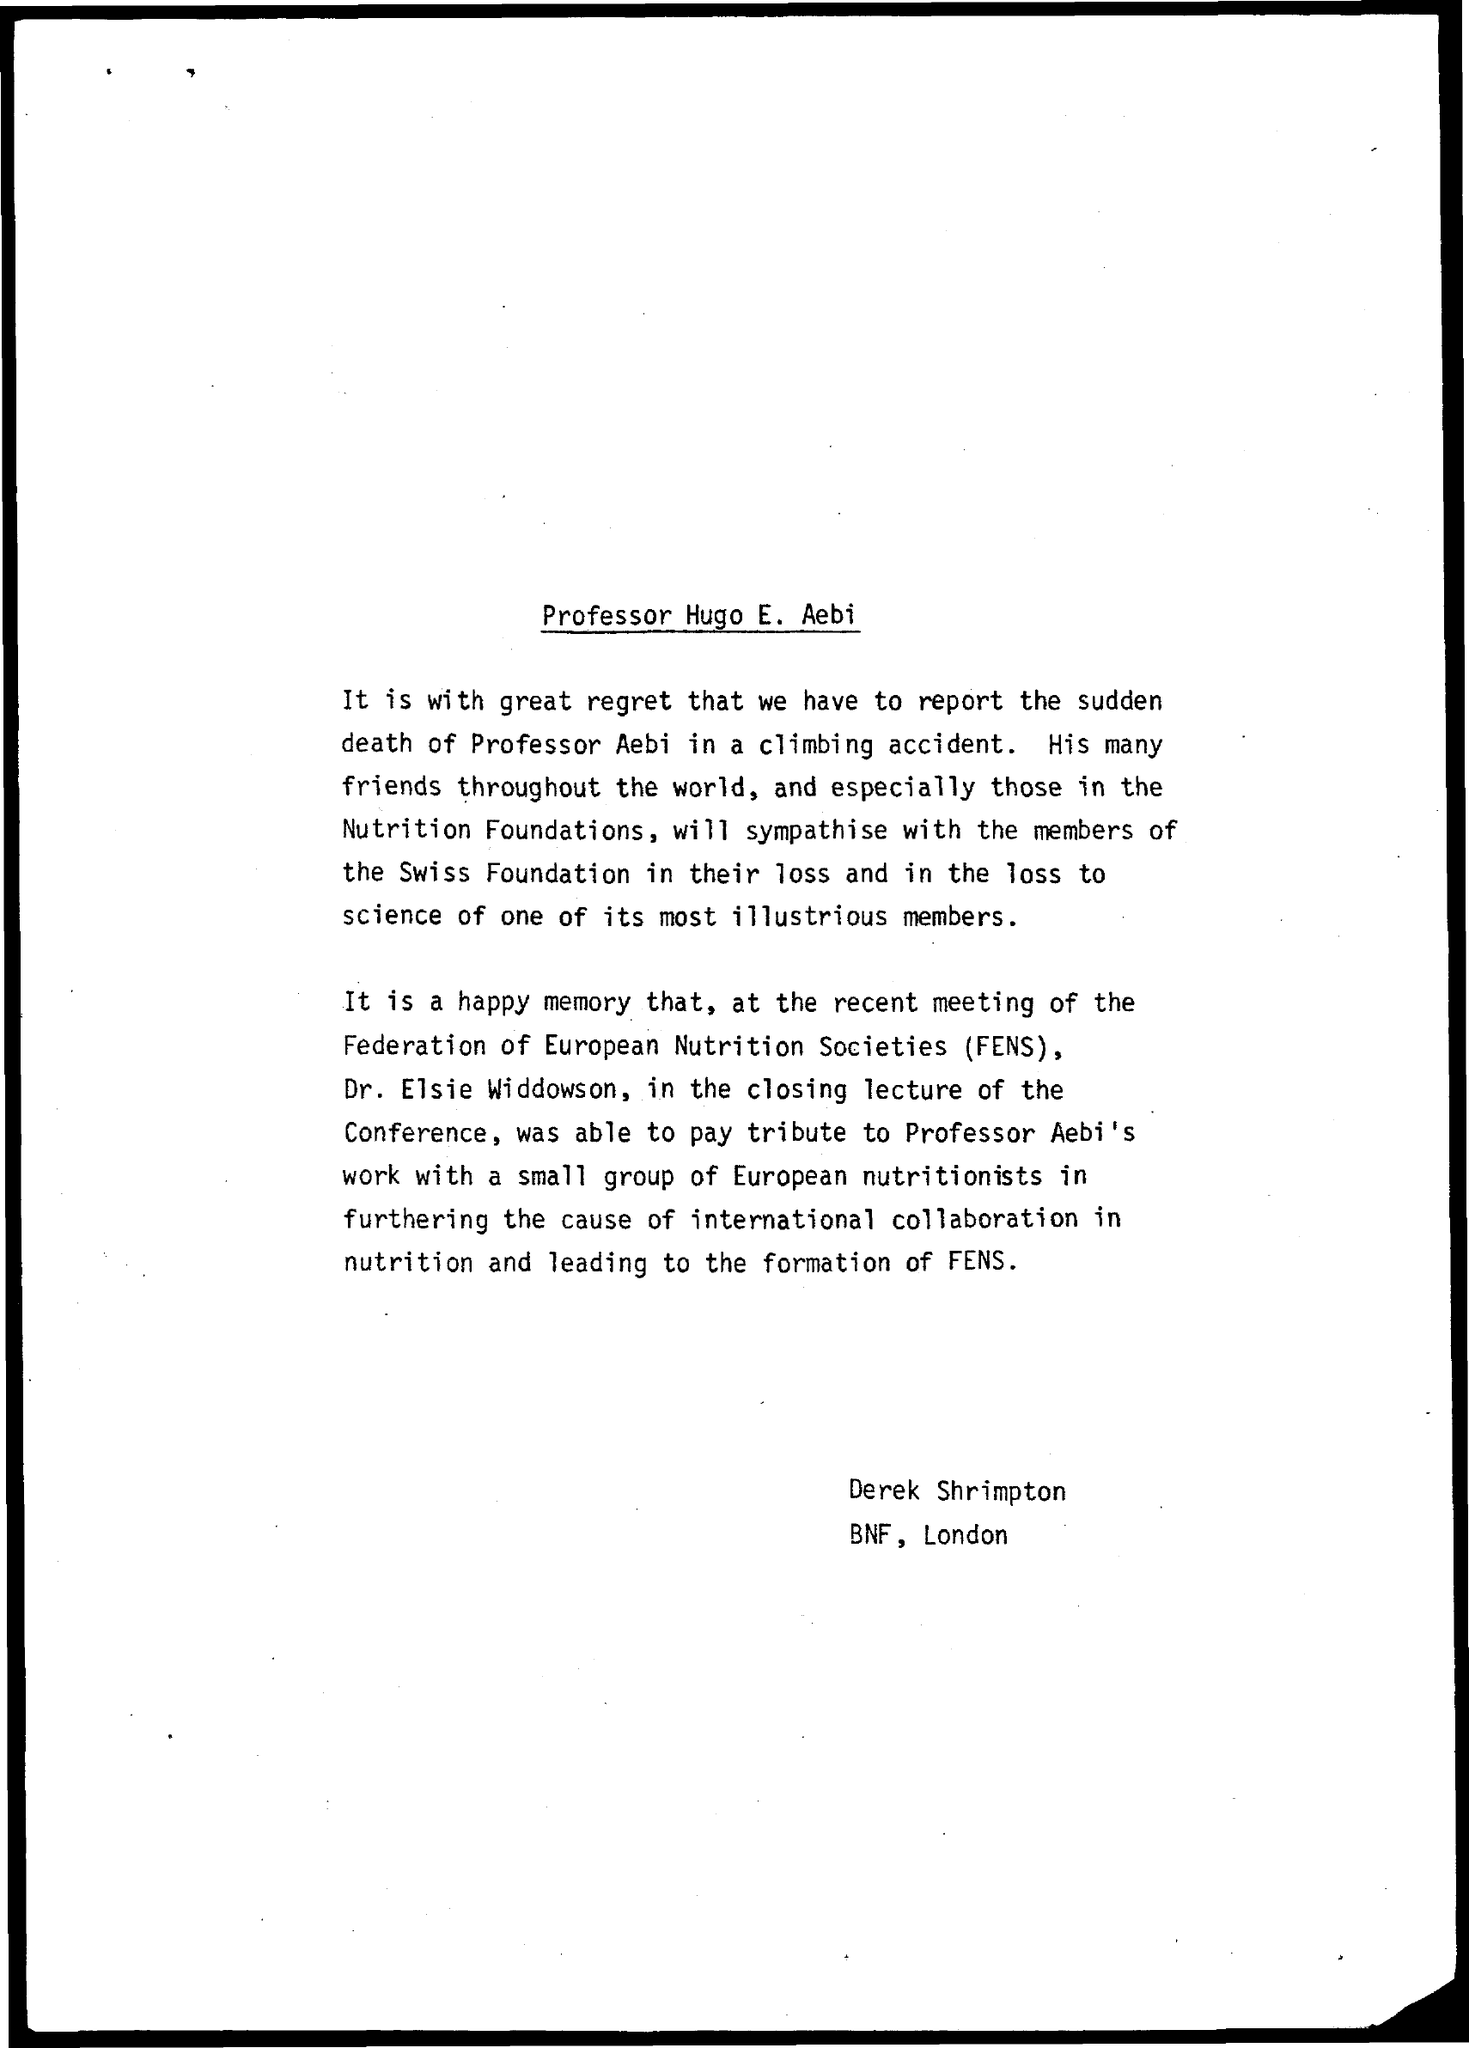Highlight a few significant elements in this photo. The Professor's name is Professor Hugo E. Aebi. 